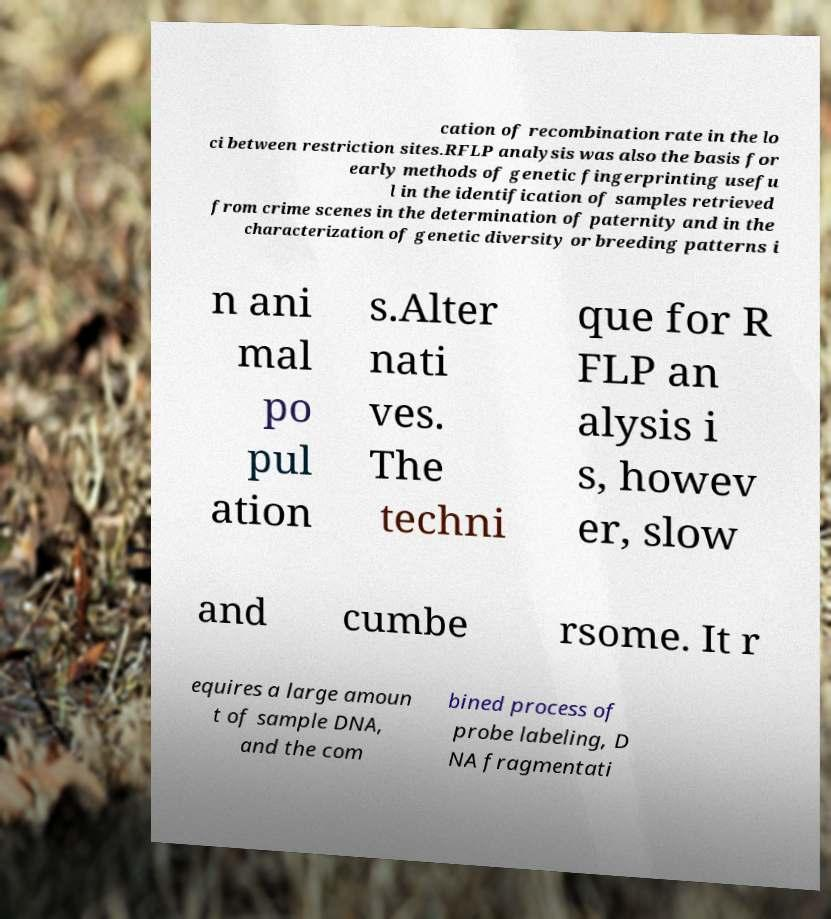What messages or text are displayed in this image? I need them in a readable, typed format. cation of recombination rate in the lo ci between restriction sites.RFLP analysis was also the basis for early methods of genetic fingerprinting usefu l in the identification of samples retrieved from crime scenes in the determination of paternity and in the characterization of genetic diversity or breeding patterns i n ani mal po pul ation s.Alter nati ves. The techni que for R FLP an alysis i s, howev er, slow and cumbe rsome. It r equires a large amoun t of sample DNA, and the com bined process of probe labeling, D NA fragmentati 